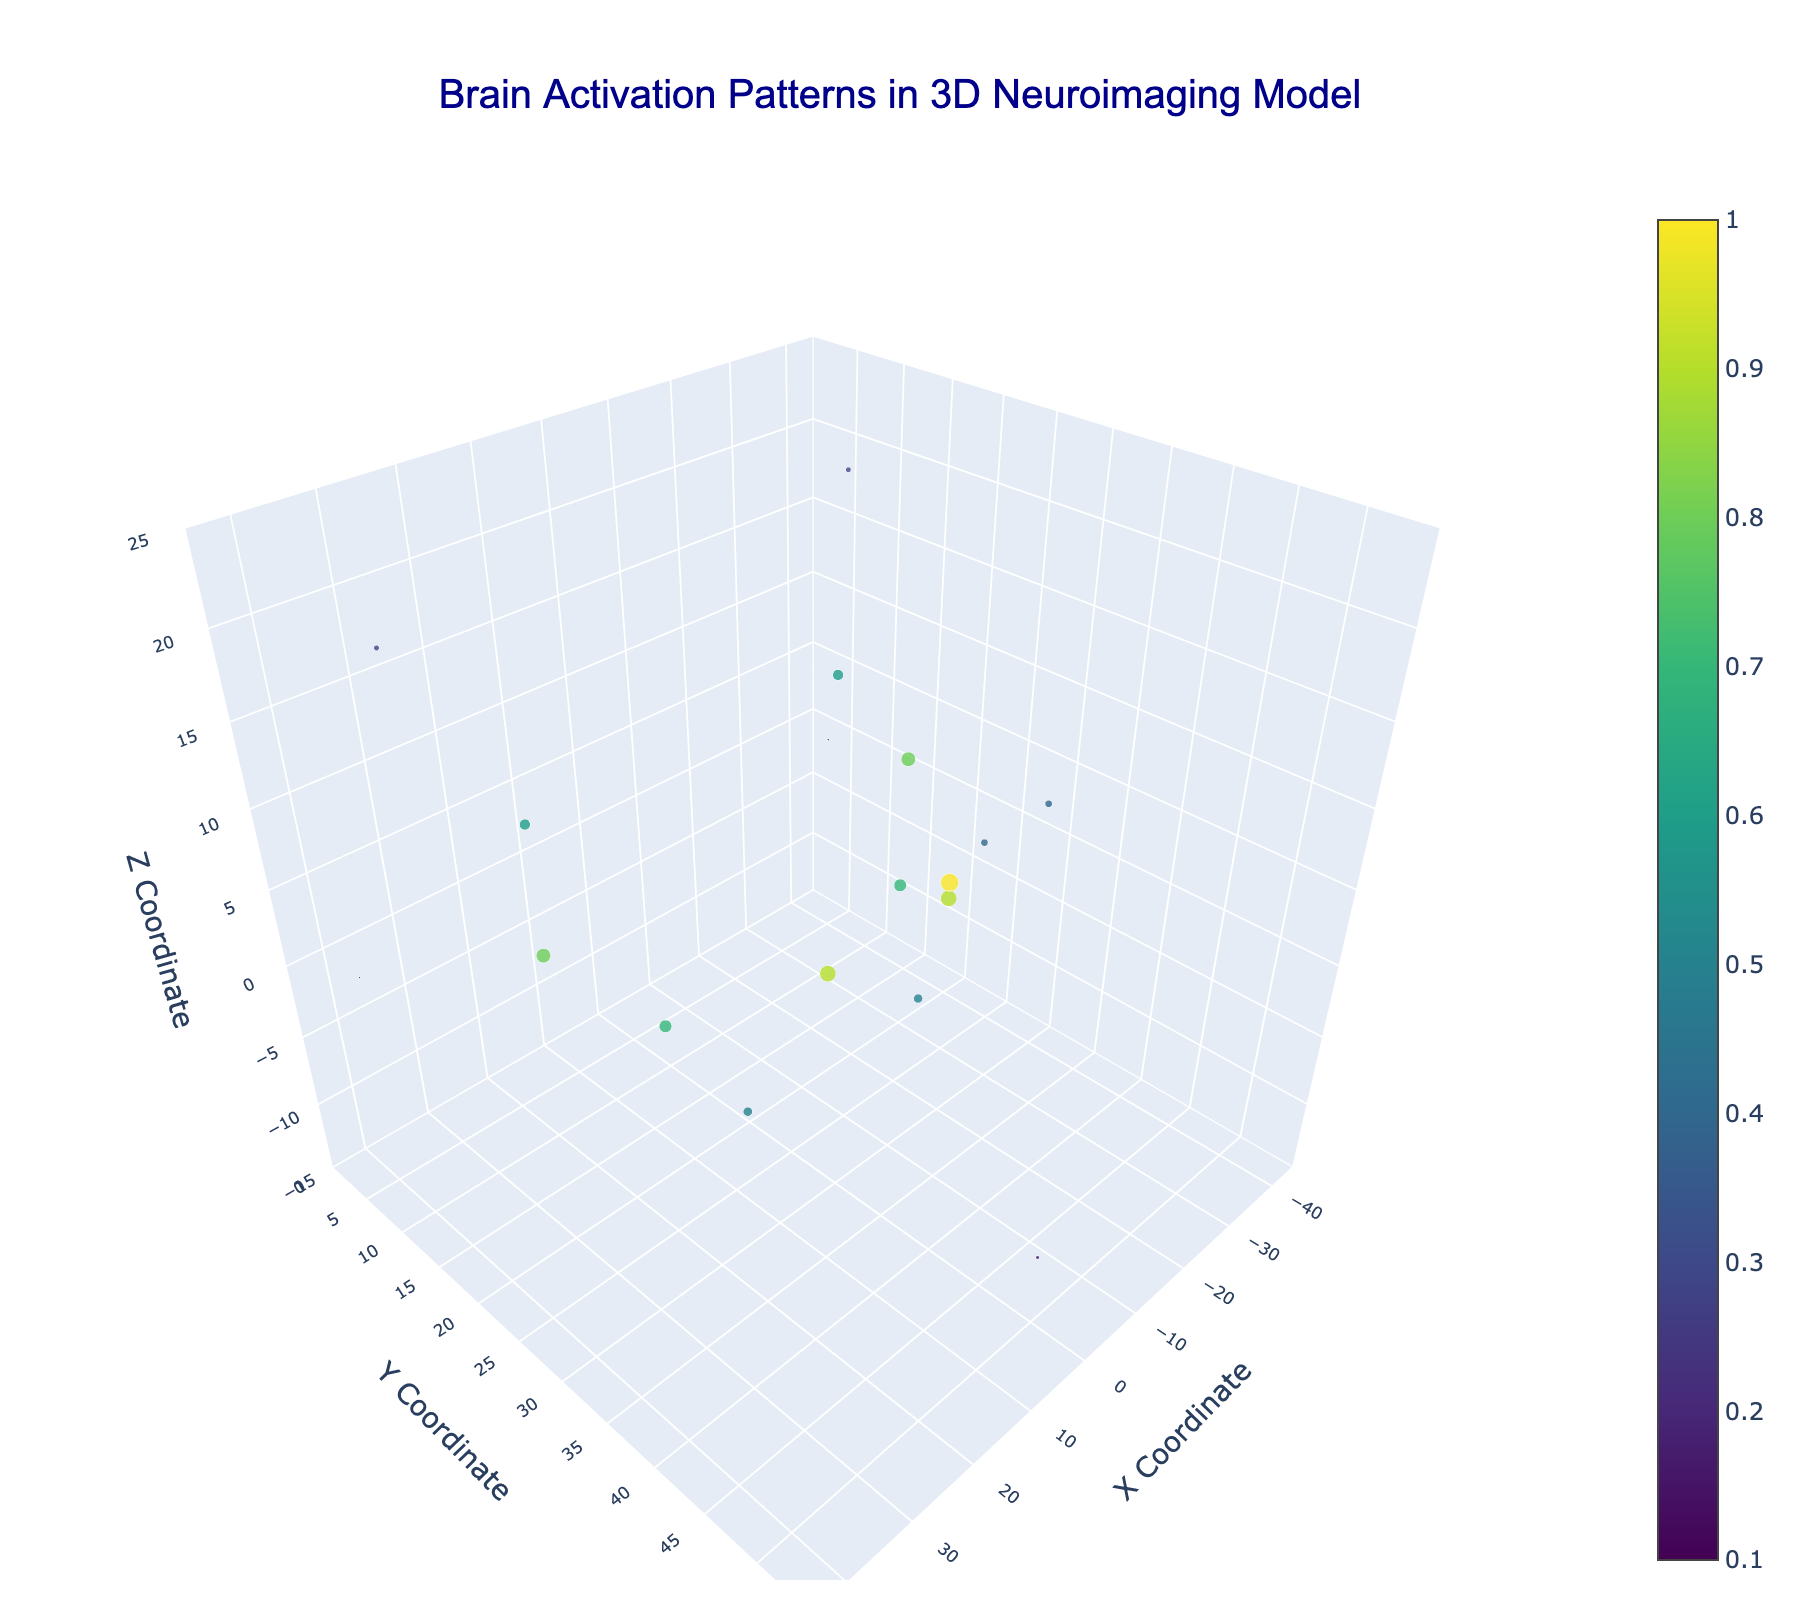What is the title of the figure? The title is the text displayed prominently at the top of the figure, centered. It reads "Brain Activation Patterns in 3D Neuroimaging Model."
Answer: Brain Activation Patterns in 3D Neuroimaging Model What color scale is used for the activation values? The color scale applied to the activation values is typically a gradient. The figure uses a color scale known as 'Viridis', which transitions from purples to yellows.
Answer: Viridis How many data points are represented in the plot? To find the number of data points, count the instances of 'markers' displayed in the Scatter3d plot component. Based on the given data, there are 18 data points.
Answer: 18 Which axis has the largest range of values? We compare the ranges of the x, y, and z axes. The x-axis ranges from -45 to 45, the y-axis ranges from 0 to 55, and the z-axis ranges from -15 to 25. The largest range is on the y-axis, which is 55 units.
Answer: y-axis What is the highest activation value, and where is it located? To identify the highest activation value, examine the data points; the highest value is 1.0. This point is located at coordinates (0, 40, 10).
Answer: 1.0 at (0, 40, 10) Which activation values are less than 0.3, and where are they located? Look for activation values less than 0.3 in the dataset: the values 0.2 (0, 50, -10), 0.1 (-40, 5, 0), and 0.1 (40, 5, 0).
Answer: 0.2 at (0, 50, -10); 0.1 at (-40, 5, 0); 0.1 at (40, 5, 0) What activation value corresponds to the point at coordinates (30, 20, 5)? By examining the data given, the point at (30, 20, 5) has an activation value of 0.8.
Answer: 0.8 How does the activation at (10, 35, 5) compare to the activation at (-10, 35, 5)? Both points have the same activation value of 0.9, indicating identical brain activation levels.
Answer: Equal Which point has the smallest marker size and what is its activation value? The smallest marker size corresponds to the smallest activation value. Activation of 0.1 has the smallest marker sizes; these occur at (-40, 5, 0) and (40, 5, 0).
Answer: 0.1 What is the average activation value of all data points? Sum the activation values (0.8 + 0.6 + 0.7 + 0.5 + 0.9 + 1.0 + 0.9 + 0.5 + 0.7 + 0.6 + 0.8 + 0.4 + 0.4 + 0.3 + 0.3 + 0.2 + 0.1 + 0.1 = 9.8). Then divide by the number of points (9.8 / 18).
Answer: 0.544 